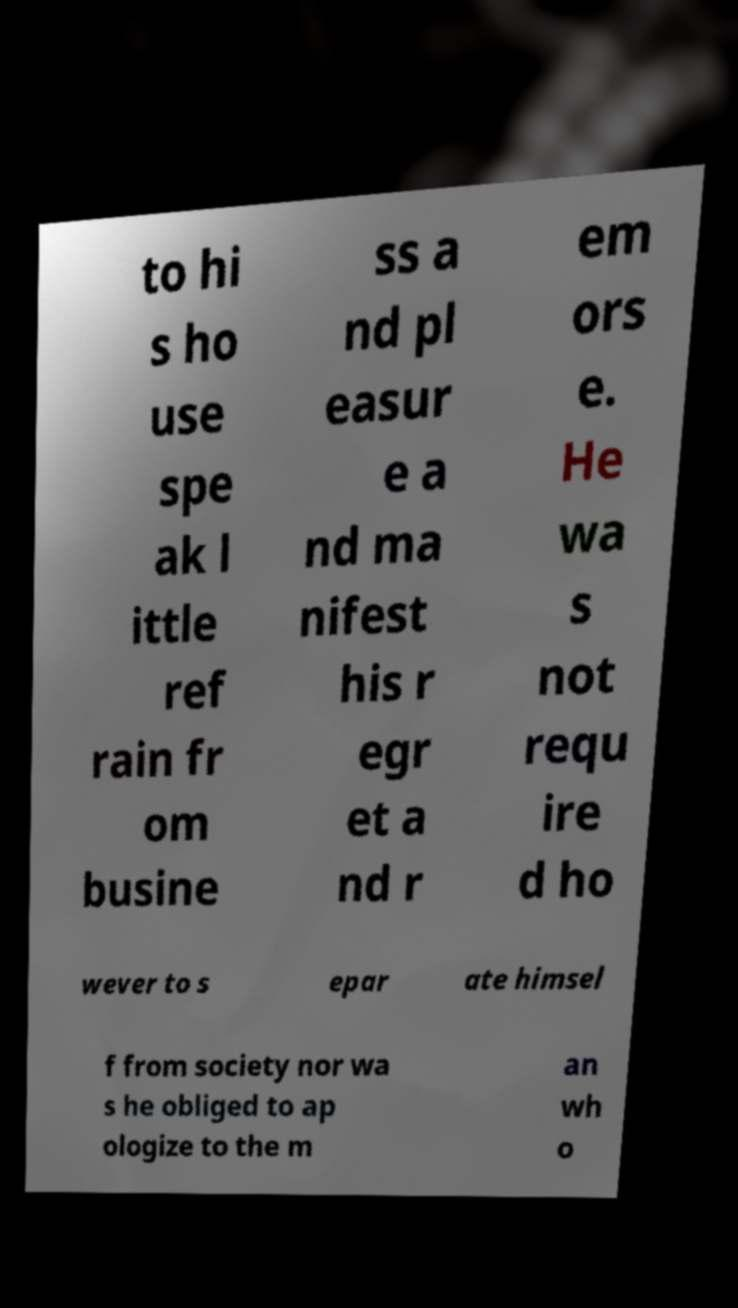Could you assist in decoding the text presented in this image and type it out clearly? to hi s ho use spe ak l ittle ref rain fr om busine ss a nd pl easur e a nd ma nifest his r egr et a nd r em ors e. He wa s not requ ire d ho wever to s epar ate himsel f from society nor wa s he obliged to ap ologize to the m an wh o 